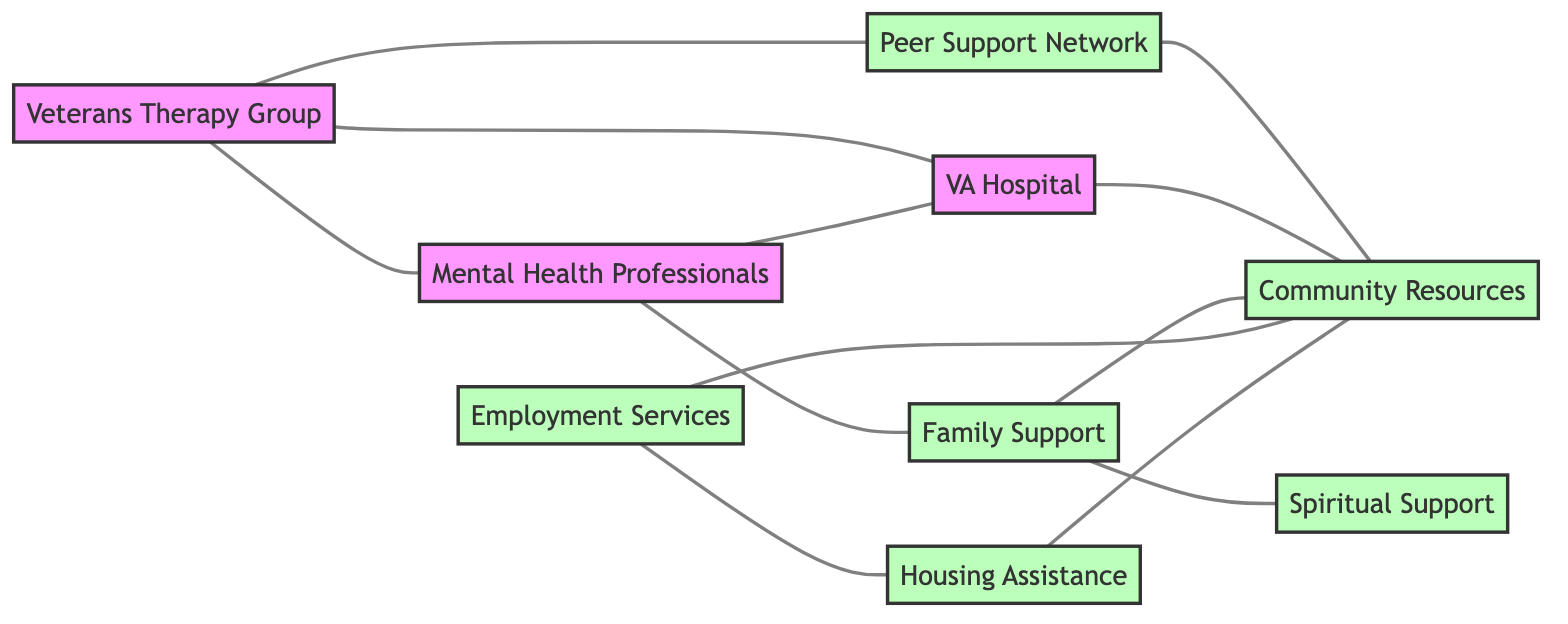What is the total number of nodes in the diagram? The diagram includes the following nodes: Veterans Therapy Group, Mental Health Professionals, Family Support, Peer Support Network, VA Hospital, Employment Services, Housing Assistance, Community Resources, and Spiritual Support. When counting these nodes, we find there are 9 distinct nodes.
Answer: 9 Which node connects directly to the Veterans Therapy Group? The Veterans Therapy Group has edges connecting it to Mental Health Professionals, Peer Support Network, and VA Hospital. Therefore, the nodes that connect directly to it are listed.
Answer: Mental Health Professionals, Peer Support Network, VA Hospital How many edges are there in the diagram? To determine the number of edges, we can count the connections (or lines) between the nodes. The edges listed are: Veterans Therapy Group to Mental Health Professionals, Peer Support Network, and VA Hospital; Mental Health Professionals to VA Hospital and Family Support; Peer Support Network to Community Resources; and other connections until all are counted. The total adds up to 12 edges.
Answer: 12 What is the relationship between Family Support and Spiritual Support? In the diagram, Family Support has a direct edge to Spiritual Support, implying a direct relationship. There is no other connection mentioned between them aside from this edge.
Answer: Direct connection Which support systems are linked to Community Resources? Community Resources is connected to the following support systems: Peer Support Network, VA Hospital, Family Support, Employment Services, and Housing Assistance. Thus, these are the systems indicating support to the Community Resources in the diagram.
Answer: Peer Support Network, VA Hospital, Family Support, Employment Services, Housing Assistance How many nodes are support systems in this diagram? The nodes classified as support systems in the diagram include Family Support, Peer Support Network, Employment Services, Housing Assistance, Community Resources, and Spiritual Support. Counting these, we find there are 6 support system nodes.
Answer: 6 Are there any support systems that connect directly to both Employment Services and Community Resources? By checking the edges in the diagram, Employment Services has a direct connection to Community Resources. However, there is no node that connects to both directly outside of these two systems. Thus, there is no such support system that has direct connections to both nodes.
Answer: No Which node acts as a bridge between Family Support and Community Resources? Family Support has two connections: one to Spiritual Support and one to Community Resources. This indicates that Family Support is a node that can act as a bridge to reach Community Resources through its direct connection. Therefore, Family Support serves as this bridge.
Answer: Family Support 